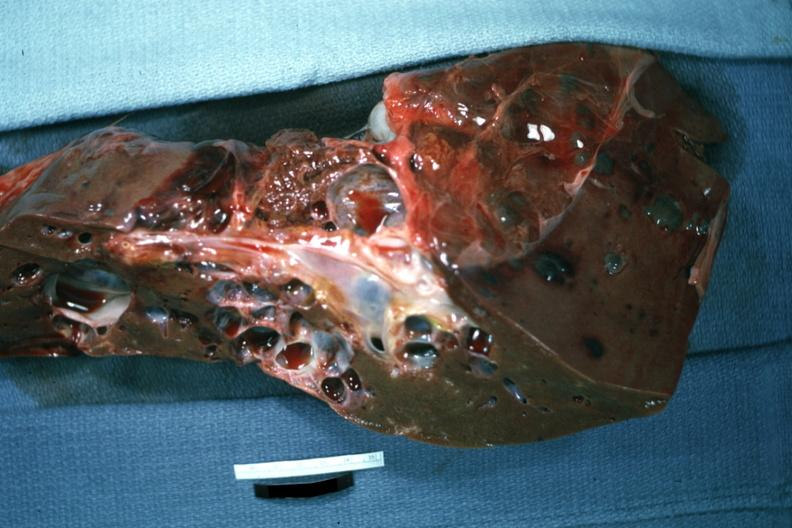what is present?
Answer the question using a single word or phrase. Liver 